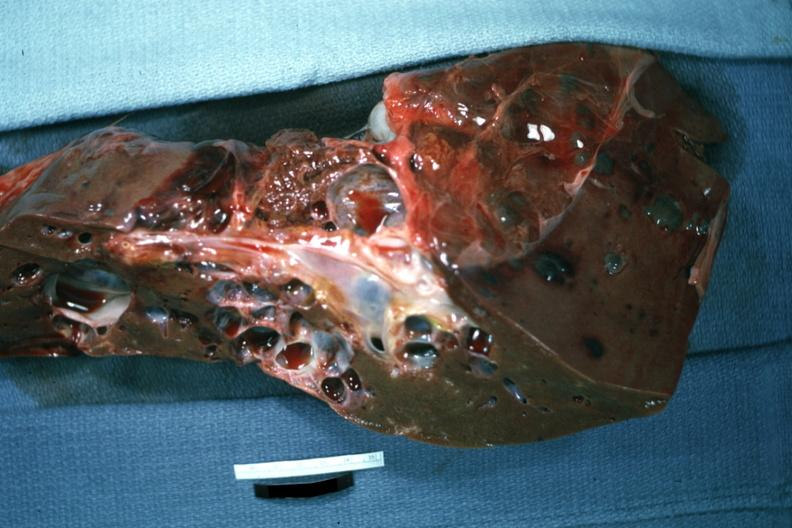what is present?
Answer the question using a single word or phrase. Liver 